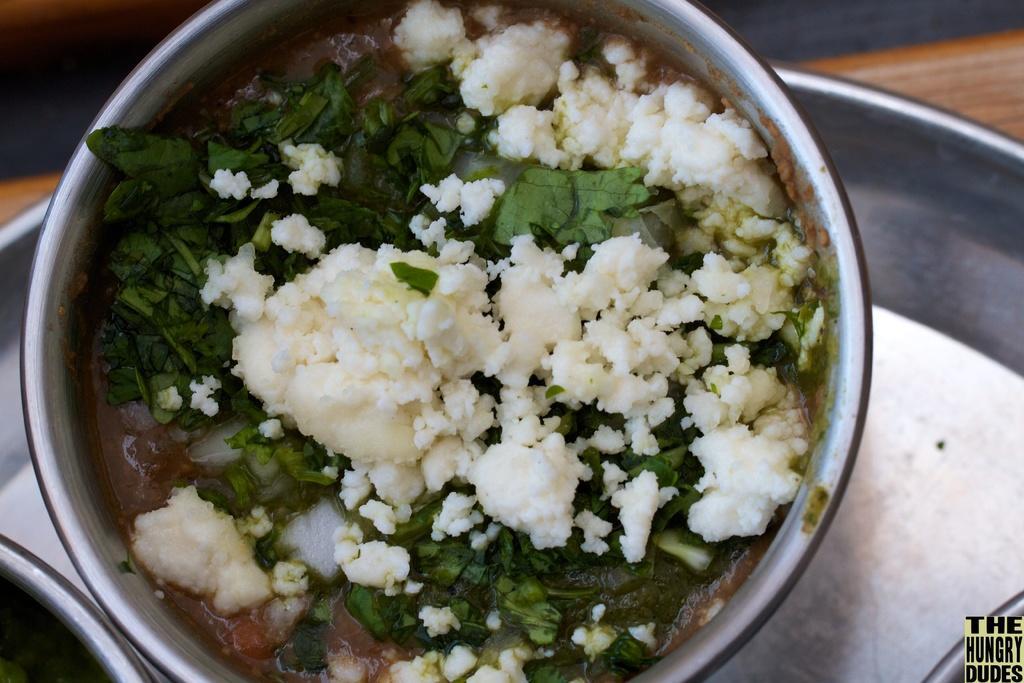Can you describe this image briefly? In this image we can see some food item which is in bowl and there is a plate on the surface. 